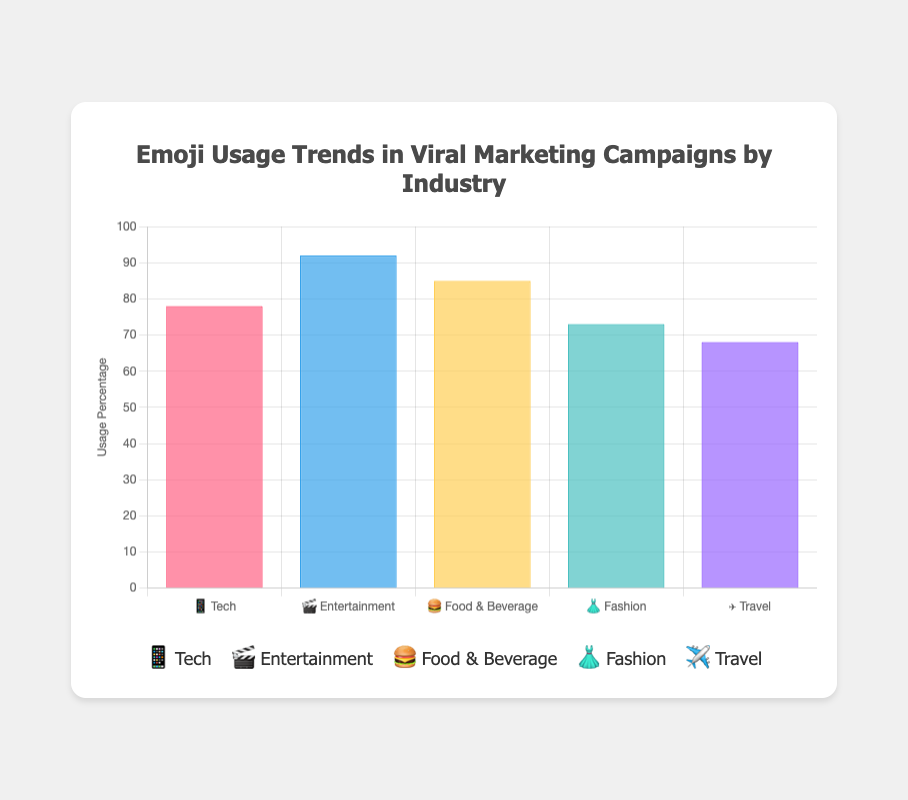What is the title of the chart? The title of the chart is located at the top and is "Emoji Usage Trends in Viral Marketing Campaigns by Industry." This title summarizes the content and focus of the chart.
Answer: Emoji Usage Trends in Viral Marketing Campaigns by Industry Which industry has the highest emoji usage percentage? The bar with the greatest height indicates the highest emoji usage percentage. The "Entertainment" industry, represented by the 🎬 emoji, has the highest usage percentage at 92%.
Answer: Entertainment How much higher is the emoji usage percentage in the Food & Beverage industry compared to the Travel industry? The emoji usage percentage for the Food & Beverage industry (🍔) is 85%, and for the Travel industry (✈️), it is 68%. The difference is calculated as 85% - 68% = 17%.
Answer: 17% What is the average emoji usage percentage across all industries? To find the average, add all the percentages and divide by the number of industries: (78 + 92 + 85 + 73 + 68) / 5 = 79.2%.
Answer: 79.2% Which trending emojis are associated with the Tech industry? By referring to the tooltip information, the Tech industry (📱) lists trending emojis as 🚀, 💡, 🤖, 🔥, and ✨.
Answer: 🚀, 💡, 🤖, 🔥, ✨ Rank the industries from the highest to the lowest emoji usage percentage. By comparing the bar heights, the order from highest to lowest usage percentage is: Entertainment (🎬), Food & Beverage (🍔), Tech (📱), Fashion (👗), Travel (✈️).
Answer: Entertainment, Food & Beverage, Tech, Fashion, Travel What is the emoji usage percentage of the Fashion industry? The height of the bar for the Fashion industry (👗) indicates a usage percentage of 73%.
Answer: 73% How many industries have an emoji usage percentage greater than 75%? By examining the chart, count the industries with bars above the 75% mark. The industries are Entertainment (92%), Food & Beverage (85%), and Tech (78%). Therefore, three industries meet the criteria.
Answer: 3 Which two industries have the smallest difference in emoji usage percentage? Comparing the differences between the emoji usage percentages of all industries, Tech (78%) and Fashion (73%) have the smallest difference, which is 78% - 73% = 5%.
Answer: Tech and Fashion What percentage of the total usage does the Tech industry contribute? First, sum up the total usage percentages: 78 + 92 + 85 + 73 + 68 = 396%. Then, calculate the Tech industry's contribution: (78 / 396) * 100 ≈ 19.7%.
Answer: 19.7% 